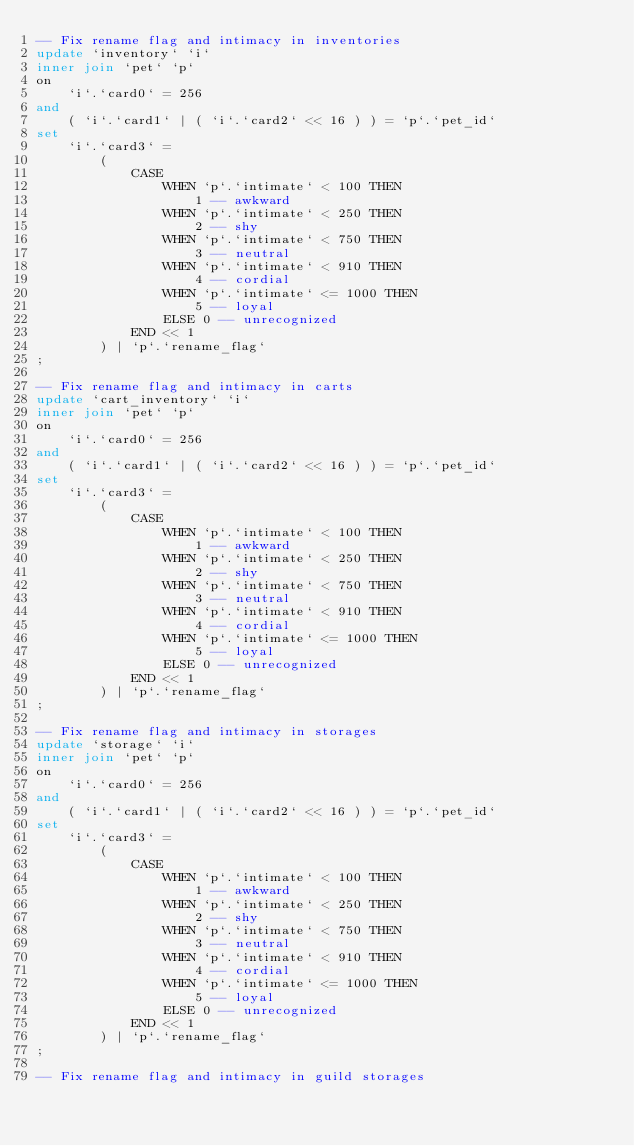<code> <loc_0><loc_0><loc_500><loc_500><_SQL_>-- Fix rename flag and intimacy in inventories
update `inventory` `i`
inner join `pet` `p`
on
	`i`.`card0` = 256
and
	( `i`.`card1` | ( `i`.`card2` << 16 ) ) = `p`.`pet_id`
set
	`i`.`card3` = 
		( 
			CASE
				WHEN `p`.`intimate` < 100 THEN
					1 -- awkward
				WHEN `p`.`intimate` < 250 THEN
					2 -- shy
				WHEN `p`.`intimate` < 750 THEN
					3 -- neutral
				WHEN `p`.`intimate` < 910 THEN
					4 -- cordial
				WHEN `p`.`intimate` <= 1000 THEN
					5 -- loyal
				ELSE 0 -- unrecognized
			END << 1
		) | `p`.`rename_flag`
;

-- Fix rename flag and intimacy in carts
update `cart_inventory` `i`
inner join `pet` `p`
on
	`i`.`card0` = 256
and
	( `i`.`card1` | ( `i`.`card2` << 16 ) ) = `p`.`pet_id`
set
	`i`.`card3` = 
		( 
			CASE
				WHEN `p`.`intimate` < 100 THEN
					1 -- awkward
				WHEN `p`.`intimate` < 250 THEN
					2 -- shy
				WHEN `p`.`intimate` < 750 THEN
					3 -- neutral
				WHEN `p`.`intimate` < 910 THEN
					4 -- cordial
				WHEN `p`.`intimate` <= 1000 THEN
					5 -- loyal
				ELSE 0 -- unrecognized
			END << 1
		) | `p`.`rename_flag`
;

-- Fix rename flag and intimacy in storages
update `storage` `i`
inner join `pet` `p`
on
	`i`.`card0` = 256
and
	( `i`.`card1` | ( `i`.`card2` << 16 ) ) = `p`.`pet_id`
set
	`i`.`card3` = 
		( 
			CASE
				WHEN `p`.`intimate` < 100 THEN
					1 -- awkward
				WHEN `p`.`intimate` < 250 THEN
					2 -- shy
				WHEN `p`.`intimate` < 750 THEN
					3 -- neutral
				WHEN `p`.`intimate` < 910 THEN
					4 -- cordial
				WHEN `p`.`intimate` <= 1000 THEN
					5 -- loyal
				ELSE 0 -- unrecognized
			END << 1
		) | `p`.`rename_flag`
;

-- Fix rename flag and intimacy in guild storages</code> 